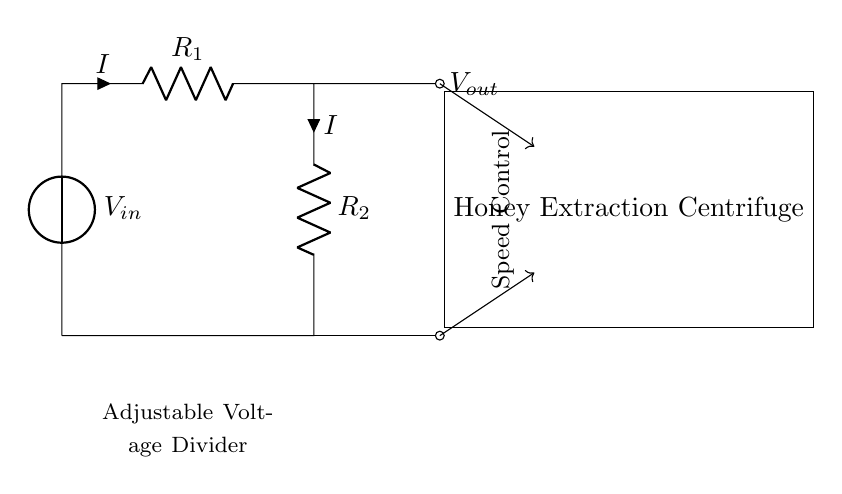What is the input voltage of the circuit? The input voltage is labeled as V in the circuit diagram, indicating that it's the supplied voltage to the voltage divider.
Answer: V in What are the two resistors in the circuit? The resistors in the circuit are labeled R1 and R2. They are components that make up the voltage divider, providing voltage division based on their resistance values.
Answer: R1 and R2 What is the purpose of this circuit? The purpose of this circuit, as indicated by the speed control label, is to adjust the speed of the honey extraction centrifuge by varying the output voltage.
Answer: Adjust speed How can the output voltage be controlled? The output voltage can be controlled by changing the resistance values of R1 and R2, as they determine how voltage divides across the resistors.
Answer: Changing resistances What happens to the output voltage if R1 is increased? If R1 is increased, the output voltage V out will decrease, because a larger proportion of the input voltage drops across R1, resulting in less voltage across R2.
Answer: Decreases What is the relationship between input voltage and output voltage? The relationship between input voltage and output voltage is given by the voltage divider formula, where V out is proportional to the ratio of R2 to the total resistance R1 + R2, multiplied by V in.
Answer: Proportional 